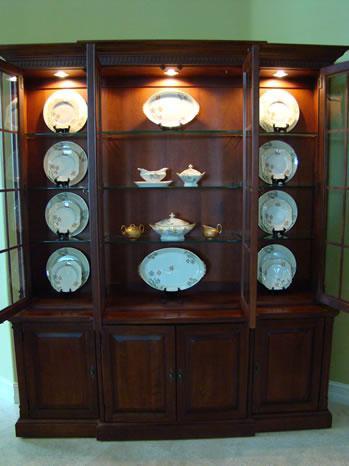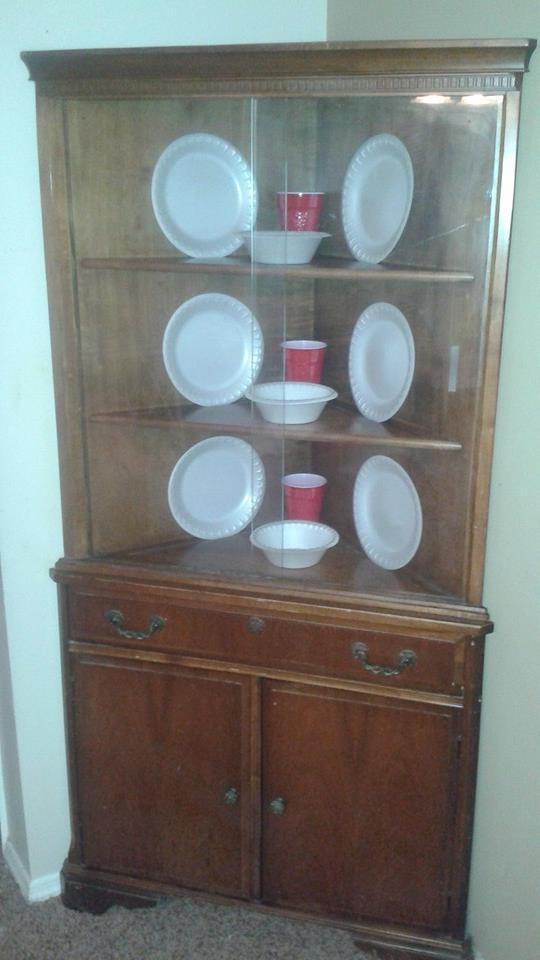The first image is the image on the left, the second image is the image on the right. Analyze the images presented: Is the assertion "A wooden hutch with three rows of dishes in its upper glass-paned section has three drawers between two doors in its lower section." valid? Answer yes or no. No. The first image is the image on the left, the second image is the image on the right. Considering the images on both sides, is "The cabinet in the image on the right is set in the corner of a room." valid? Answer yes or no. Yes. 